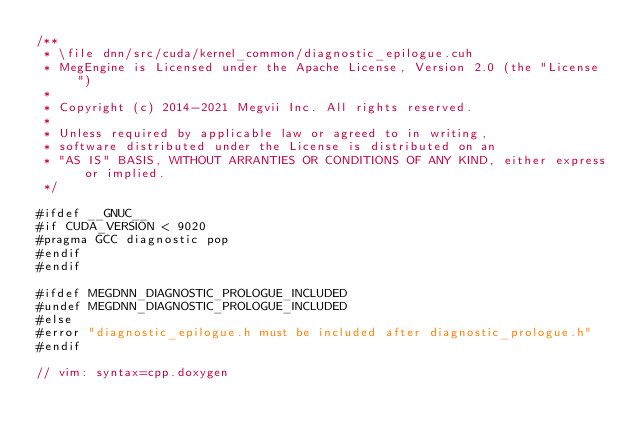<code> <loc_0><loc_0><loc_500><loc_500><_Cuda_>/**
 * \file dnn/src/cuda/kernel_common/diagnostic_epilogue.cuh
 * MegEngine is Licensed under the Apache License, Version 2.0 (the "License")
 *
 * Copyright (c) 2014-2021 Megvii Inc. All rights reserved.
 *
 * Unless required by applicable law or agreed to in writing,
 * software distributed under the License is distributed on an
 * "AS IS" BASIS, WITHOUT ARRANTIES OR CONDITIONS OF ANY KIND, either express or implied.
 */

#ifdef __GNUC__
#if CUDA_VERSION < 9020
#pragma GCC diagnostic pop
#endif
#endif

#ifdef MEGDNN_DIAGNOSTIC_PROLOGUE_INCLUDED
#undef MEGDNN_DIAGNOSTIC_PROLOGUE_INCLUDED
#else
#error "diagnostic_epilogue.h must be included after diagnostic_prologue.h"
#endif

// vim: syntax=cpp.doxygen
</code> 